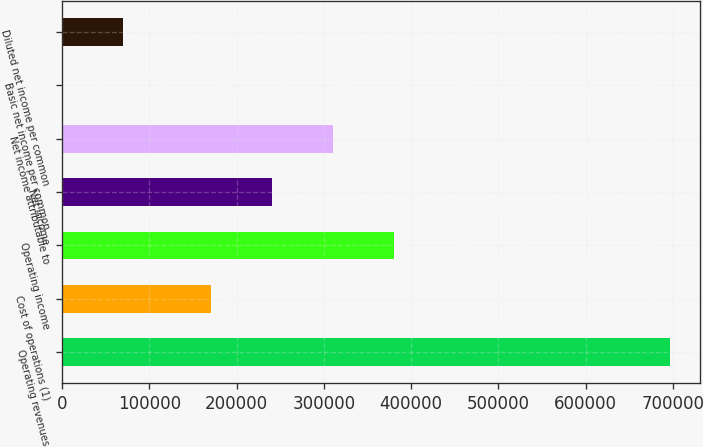Convert chart. <chart><loc_0><loc_0><loc_500><loc_500><bar_chart><fcel>Operating revenues<fcel>Cost of operations (1)<fcel>Operating income<fcel>Net income<fcel>Net income attributable to<fcel>Basic net income per common<fcel>Diluted net income per common<nl><fcel>696517<fcel>170985<fcel>379940<fcel>240637<fcel>310288<fcel>0.56<fcel>69652.2<nl></chart> 